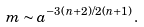Convert formula to latex. <formula><loc_0><loc_0><loc_500><loc_500>m \sim a ^ { - 3 ( n + 2 ) / 2 ( n + 1 ) } \, .</formula> 